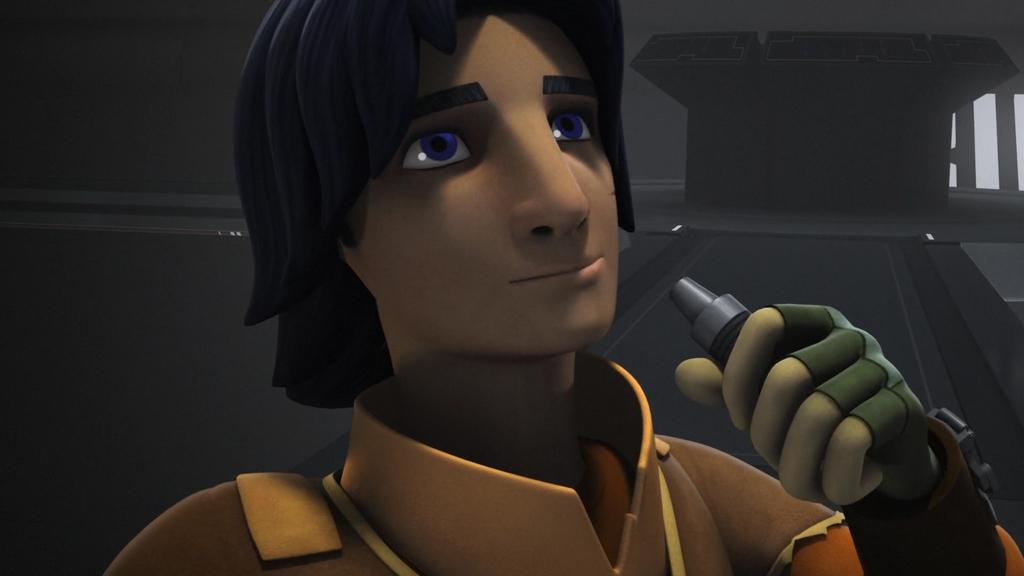What type of media is the image? The image is an animation. Can you describe the person in the animation? There is a person in the animation. What is the person holding in the animation? The person is holding an object. What can be seen in the background of the animation? There is a wall and another object in the background of the animation. What type of wax can be seen melting in the animation? There is no wax present in the animation. How does the business operate in the animation? There is no business depicted in the animation. 